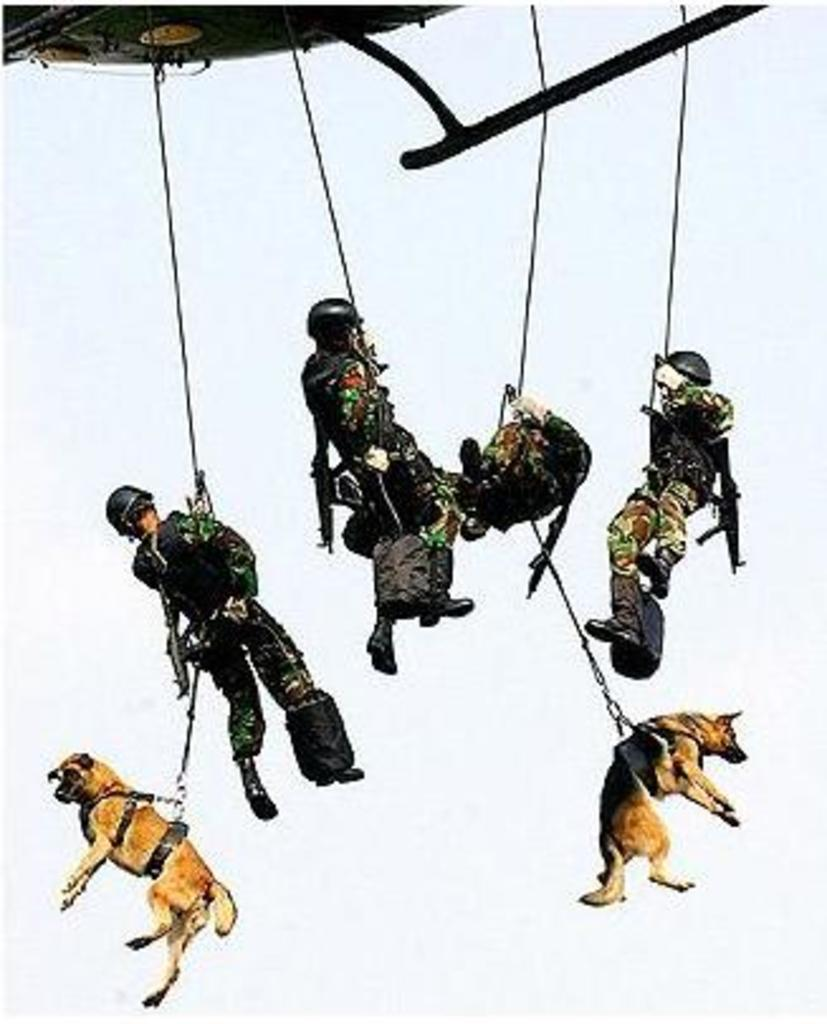What is the main subject of the image? The main subject of the image is a helicopter. What are the people in the image doing? The people in the image are hanging on ropes. What else is hanging on ropes in the image? Dogs are also hanging on ropes in the image. What type of butter is being used by the minister in the image? There is no minister or butter present in the image. What is the view like from the helicopter in the image? The provided facts do not mention the view from the helicopter, so we cannot answer this question based on the information given. 